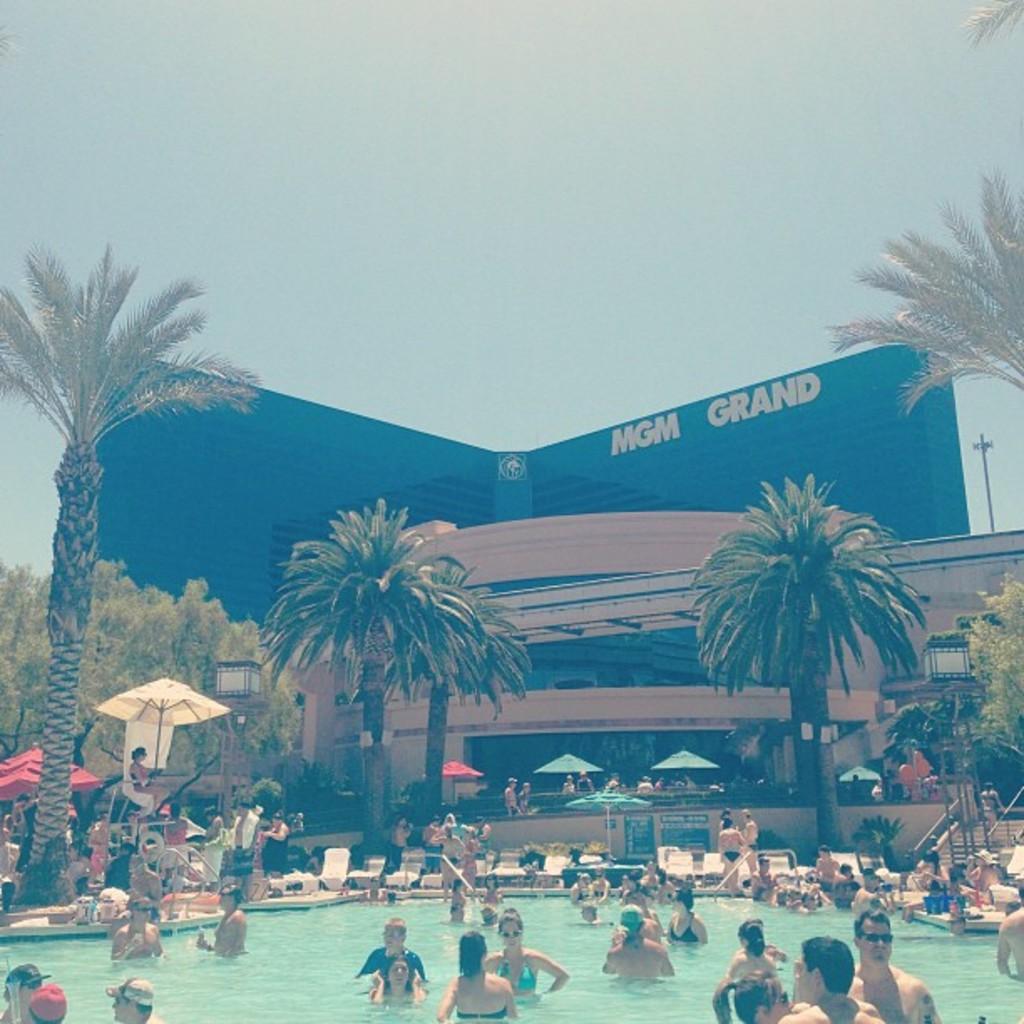Could you give a brief overview of what you see in this image? There is a swimming pool. In that there are many people. In the back there are umbrellas, trees and buildings. Also there are steps on the right side. In the back there is sky. 